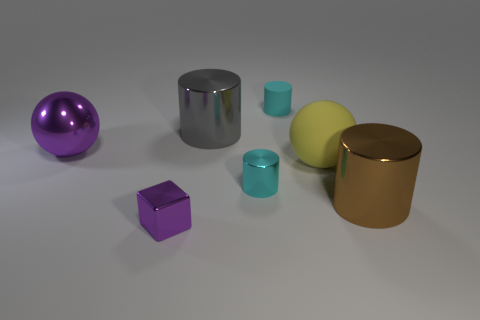Subtract all metallic cylinders. How many cylinders are left? 1 Add 2 large brown matte cylinders. How many objects exist? 9 Subtract all gray cylinders. How many cylinders are left? 3 Subtract all blocks. How many objects are left? 6 Subtract all brown metallic blocks. Subtract all large purple spheres. How many objects are left? 6 Add 6 large balls. How many large balls are left? 8 Add 3 large gray shiny balls. How many large gray shiny balls exist? 3 Subtract 0 purple cylinders. How many objects are left? 7 Subtract 1 cubes. How many cubes are left? 0 Subtract all yellow balls. Subtract all brown cylinders. How many balls are left? 1 